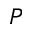Convert formula to latex. <formula><loc_0><loc_0><loc_500><loc_500>P</formula> 